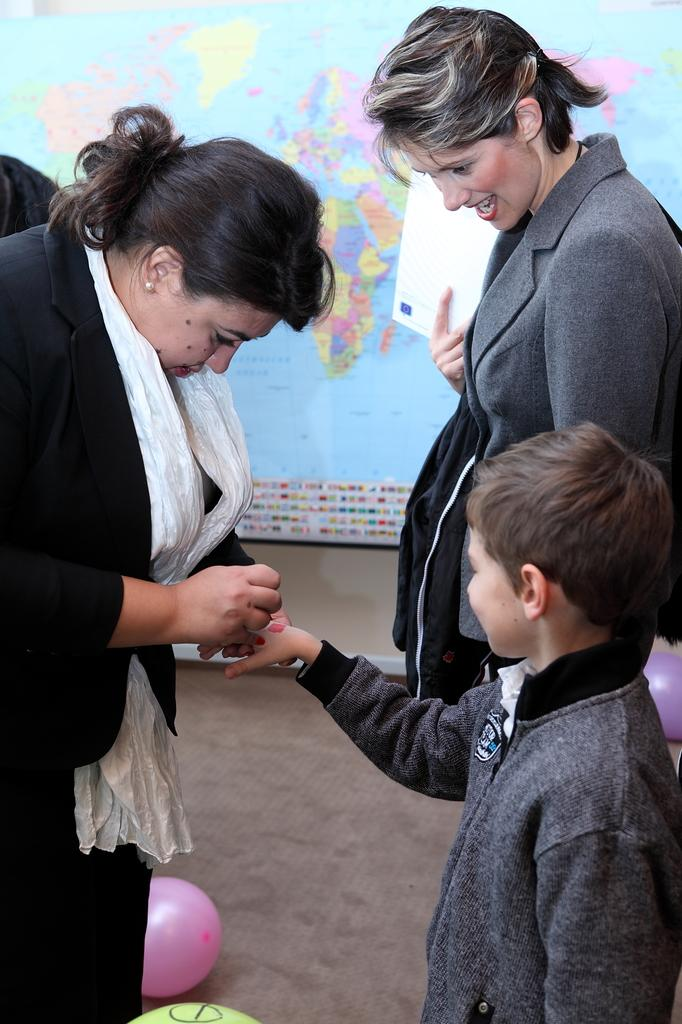What are the people in the image doing? There are people on the ground in the image, but their specific actions are not mentioned. What is the woman holding in the image? The woman is holding a paper in the image. What decorative items can be seen in the image? There are balloons visible in the image. What can be seen in the background of the image? There is a wall and a world map chart present in the background of the image. Can you tell me how many people are getting a haircut in the image? There is no mention of a haircut or any hair-related activity in the image. What type of cup is being used to serve the drinks in the image? There is no mention of drinks or cups in the image. 